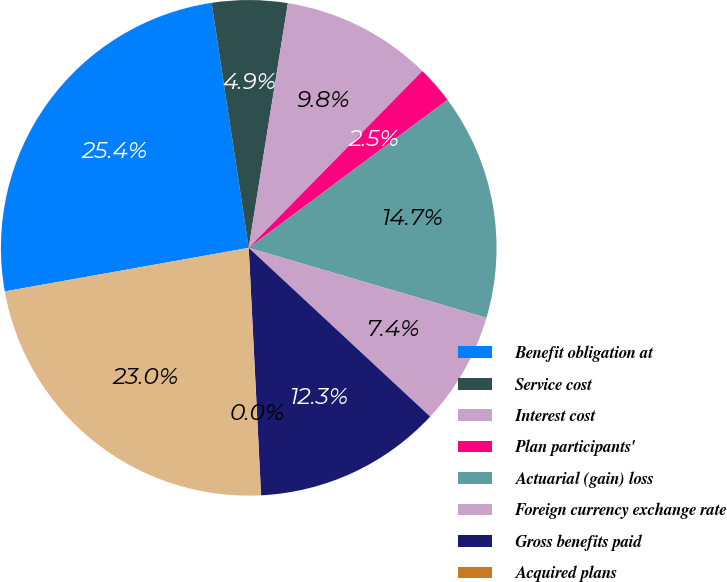Convert chart. <chart><loc_0><loc_0><loc_500><loc_500><pie_chart><fcel>Benefit obligation at<fcel>Service cost<fcel>Interest cost<fcel>Plan participants'<fcel>Actuarial (gain) loss<fcel>Foreign currency exchange rate<fcel>Gross benefits paid<fcel>Acquired plans<fcel>Benefit obligation at end of<nl><fcel>25.42%<fcel>4.92%<fcel>9.83%<fcel>2.46%<fcel>14.74%<fcel>7.37%<fcel>12.28%<fcel>0.01%<fcel>22.97%<nl></chart> 